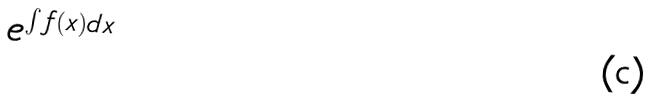<formula> <loc_0><loc_0><loc_500><loc_500>e ^ { \int f ( x ) d x }</formula> 